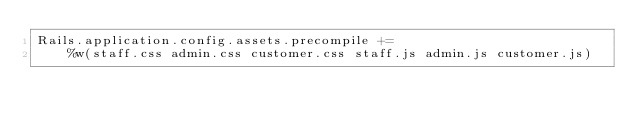<code> <loc_0><loc_0><loc_500><loc_500><_Ruby_>Rails.application.config.assets.precompile +=
    %w(staff.css admin.css customer.css staff.js admin.js customer.js)
</code> 